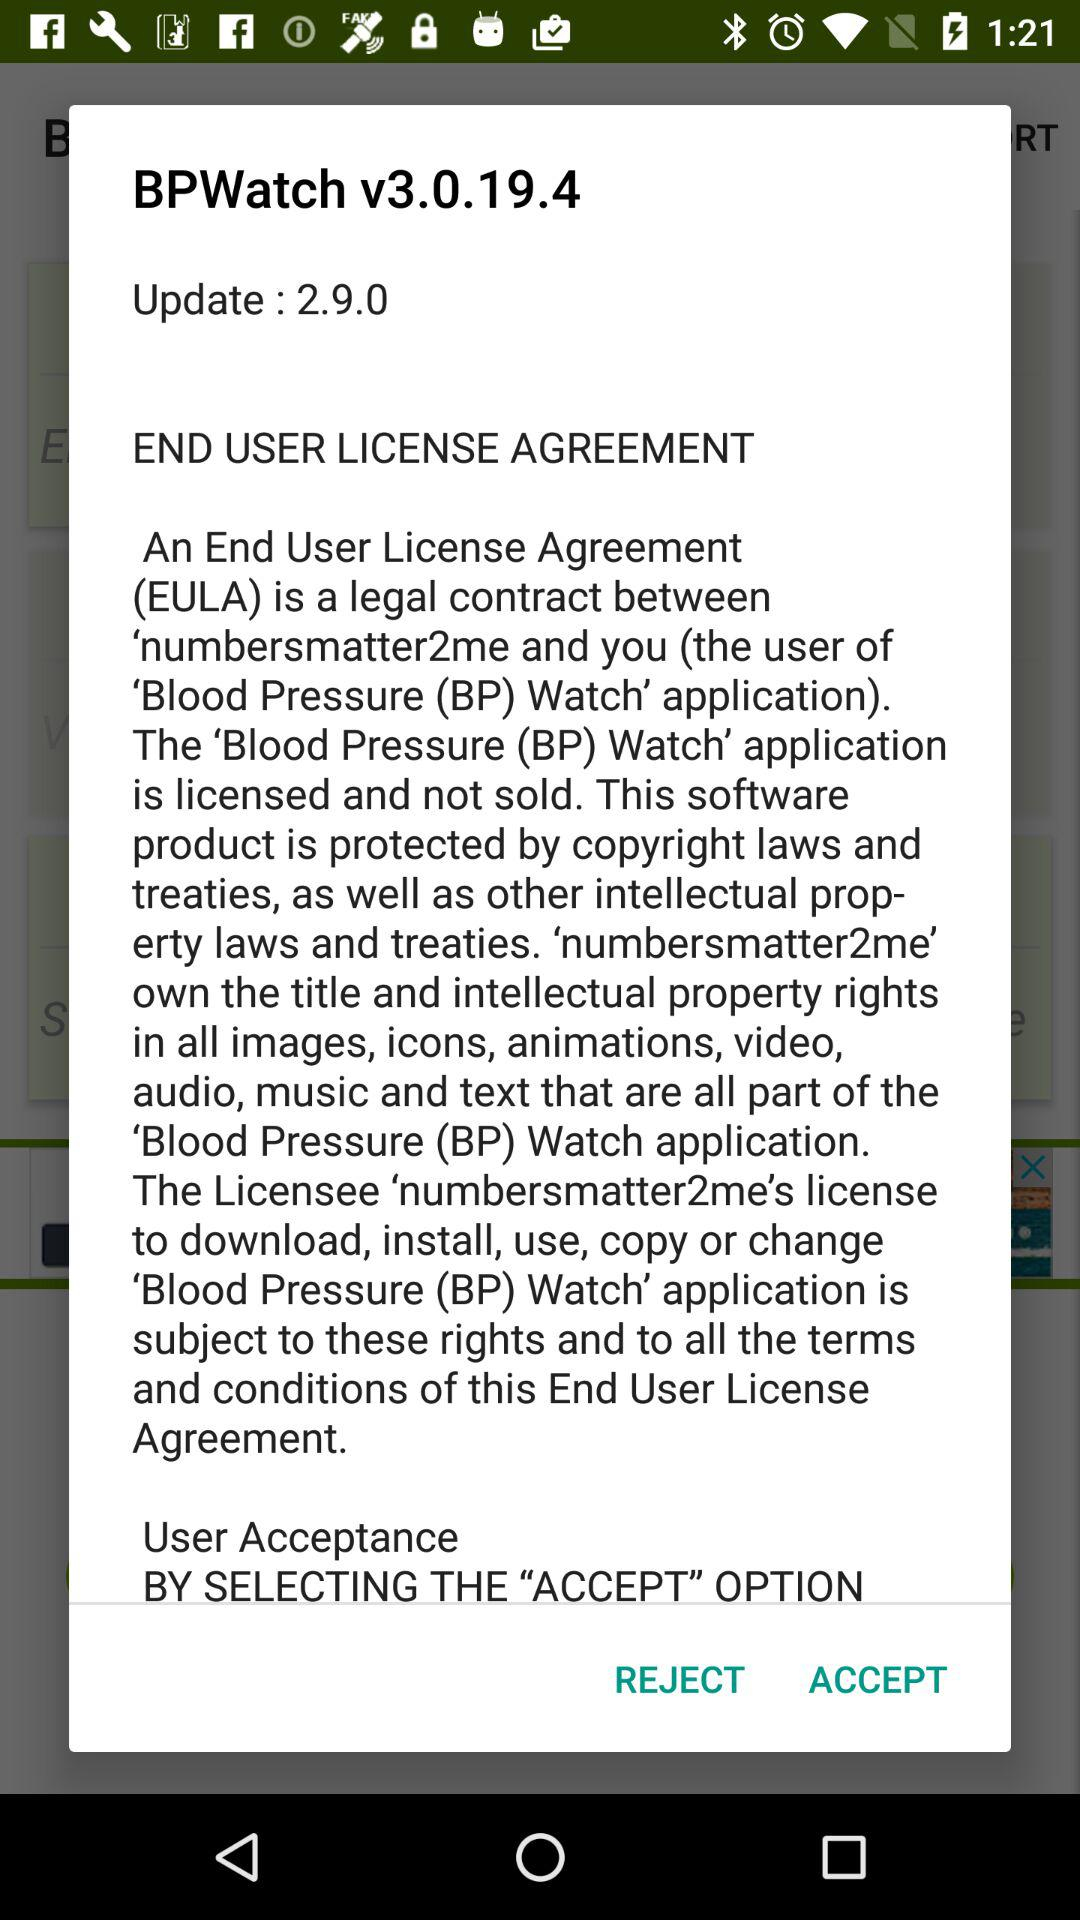What is the short form of the End User License Agreement? The short form is EULA. 